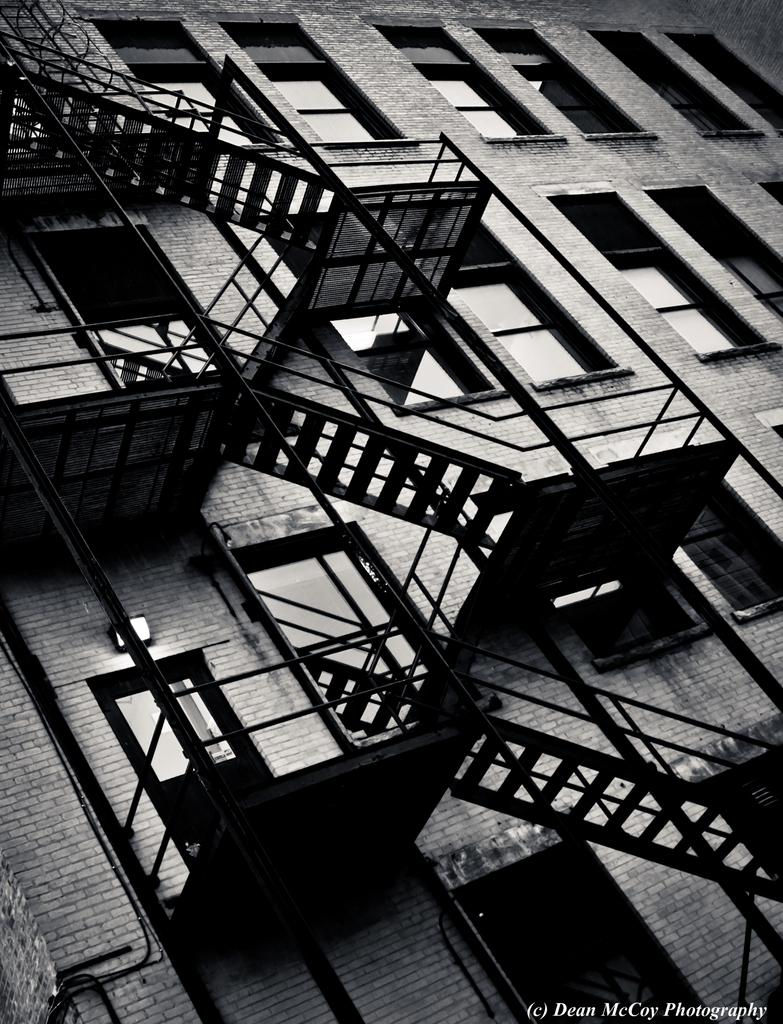What is the color scheme of the image? The image is black and white. What type of structure is present in the image? There is a building in the image. What feature of the building is mentioned in the facts? The building has windows. Are there any architectural elements visible in the image? Yes, there is a staircase in the image. What can be found at the bottom of the image? There is text at the bottom of the image. How many muscles can be seen flexing on the door in the image? There is no door present in the image, and therefore no muscles can be seen flexing on it. What type of nut is depicted in the image? There is no nut depicted in the image. 